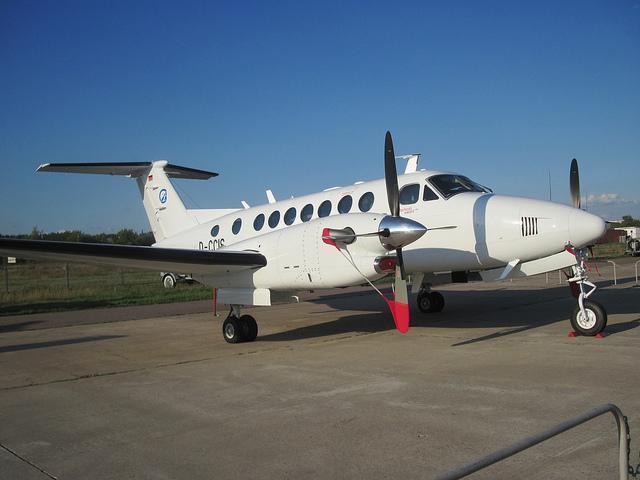How many propellers are on the plane?
Give a very brief answer. 2. How many planes are in the picture?
Give a very brief answer. 1. How many blades are on the propeller?
Give a very brief answer. 4. How many engines on the plane?
Give a very brief answer. 2. How many people are wearing glasses?
Give a very brief answer. 0. 